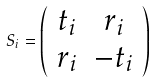Convert formula to latex. <formula><loc_0><loc_0><loc_500><loc_500>S _ { i } = \left ( \begin{array} { c c } t _ { i } & r _ { i } \\ r _ { i } & - t _ { i } \end{array} \right )</formula> 